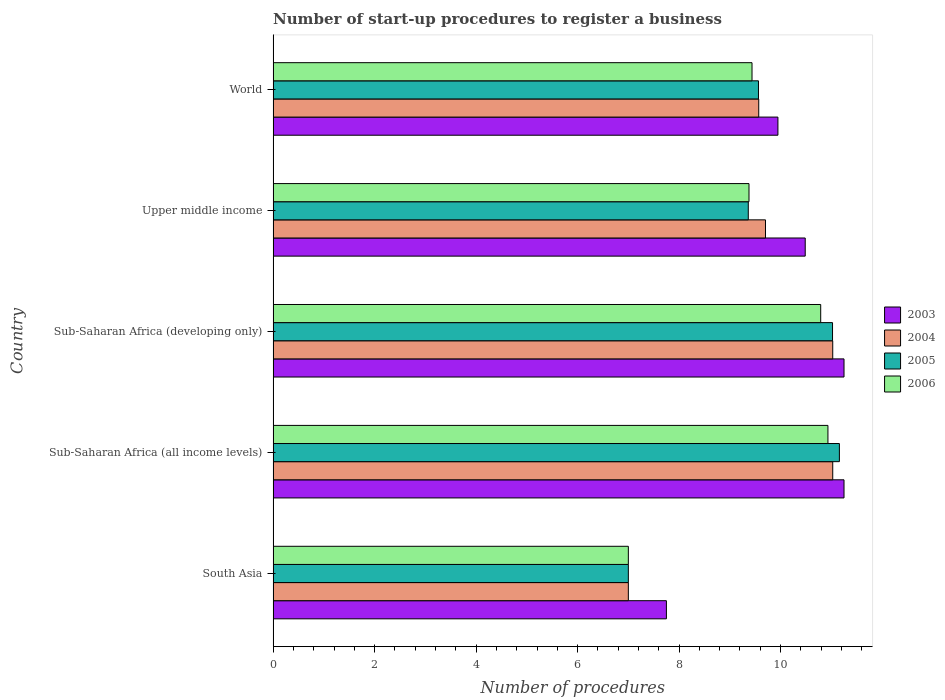How many groups of bars are there?
Offer a very short reply. 5. Are the number of bars per tick equal to the number of legend labels?
Your answer should be compact. Yes. Are the number of bars on each tick of the Y-axis equal?
Your answer should be very brief. Yes. How many bars are there on the 5th tick from the top?
Provide a short and direct response. 4. How many bars are there on the 4th tick from the bottom?
Provide a succinct answer. 4. What is the label of the 2nd group of bars from the top?
Keep it short and to the point. Upper middle income. In how many cases, is the number of bars for a given country not equal to the number of legend labels?
Provide a short and direct response. 0. What is the number of procedures required to register a business in 2006 in World?
Offer a very short reply. 9.44. Across all countries, what is the maximum number of procedures required to register a business in 2006?
Offer a terse response. 10.93. Across all countries, what is the minimum number of procedures required to register a business in 2006?
Provide a succinct answer. 7. In which country was the number of procedures required to register a business in 2006 maximum?
Your answer should be very brief. Sub-Saharan Africa (all income levels). In which country was the number of procedures required to register a business in 2003 minimum?
Offer a terse response. South Asia. What is the total number of procedures required to register a business in 2004 in the graph?
Offer a terse response. 48.33. What is the difference between the number of procedures required to register a business in 2004 in Sub-Saharan Africa (developing only) and that in World?
Offer a very short reply. 1.46. What is the difference between the number of procedures required to register a business in 2005 in South Asia and the number of procedures required to register a business in 2004 in Upper middle income?
Offer a terse response. -2.7. What is the average number of procedures required to register a business in 2004 per country?
Provide a succinct answer. 9.67. What is the difference between the number of procedures required to register a business in 2005 and number of procedures required to register a business in 2006 in World?
Your answer should be very brief. 0.13. In how many countries, is the number of procedures required to register a business in 2003 greater than 0.8 ?
Your response must be concise. 5. What is the ratio of the number of procedures required to register a business in 2004 in South Asia to that in Upper middle income?
Provide a short and direct response. 0.72. Is the difference between the number of procedures required to register a business in 2005 in South Asia and Upper middle income greater than the difference between the number of procedures required to register a business in 2006 in South Asia and Upper middle income?
Ensure brevity in your answer.  Yes. What is the difference between the highest and the second highest number of procedures required to register a business in 2003?
Offer a very short reply. 0. What is the difference between the highest and the lowest number of procedures required to register a business in 2006?
Make the answer very short. 3.93. In how many countries, is the number of procedures required to register a business in 2005 greater than the average number of procedures required to register a business in 2005 taken over all countries?
Your response must be concise. 2. Is it the case that in every country, the sum of the number of procedures required to register a business in 2004 and number of procedures required to register a business in 2005 is greater than the sum of number of procedures required to register a business in 2003 and number of procedures required to register a business in 2006?
Keep it short and to the point. No. What does the 3rd bar from the bottom in World represents?
Provide a succinct answer. 2005. How many bars are there?
Offer a very short reply. 20. What is the difference between two consecutive major ticks on the X-axis?
Your response must be concise. 2. Are the values on the major ticks of X-axis written in scientific E-notation?
Your answer should be compact. No. Does the graph contain grids?
Provide a succinct answer. No. Where does the legend appear in the graph?
Offer a very short reply. Center right. How are the legend labels stacked?
Give a very brief answer. Vertical. What is the title of the graph?
Ensure brevity in your answer.  Number of start-up procedures to register a business. What is the label or title of the X-axis?
Your response must be concise. Number of procedures. What is the Number of procedures of 2003 in South Asia?
Ensure brevity in your answer.  7.75. What is the Number of procedures in 2004 in South Asia?
Your answer should be compact. 7. What is the Number of procedures in 2005 in South Asia?
Offer a terse response. 7. What is the Number of procedures in 2003 in Sub-Saharan Africa (all income levels)?
Offer a very short reply. 11.25. What is the Number of procedures in 2004 in Sub-Saharan Africa (all income levels)?
Offer a very short reply. 11.03. What is the Number of procedures in 2005 in Sub-Saharan Africa (all income levels)?
Offer a terse response. 11.16. What is the Number of procedures of 2006 in Sub-Saharan Africa (all income levels)?
Your response must be concise. 10.93. What is the Number of procedures in 2003 in Sub-Saharan Africa (developing only)?
Make the answer very short. 11.25. What is the Number of procedures of 2004 in Sub-Saharan Africa (developing only)?
Make the answer very short. 11.03. What is the Number of procedures of 2005 in Sub-Saharan Africa (developing only)?
Ensure brevity in your answer.  11.02. What is the Number of procedures in 2006 in Sub-Saharan Africa (developing only)?
Your answer should be compact. 10.79. What is the Number of procedures of 2003 in Upper middle income?
Make the answer very short. 10.49. What is the Number of procedures in 2004 in Upper middle income?
Provide a succinct answer. 9.7. What is the Number of procedures of 2005 in Upper middle income?
Give a very brief answer. 9.36. What is the Number of procedures of 2006 in Upper middle income?
Offer a terse response. 9.38. What is the Number of procedures in 2003 in World?
Offer a terse response. 9.95. What is the Number of procedures of 2004 in World?
Ensure brevity in your answer.  9.57. What is the Number of procedures of 2005 in World?
Your answer should be compact. 9.56. What is the Number of procedures in 2006 in World?
Provide a short and direct response. 9.44. Across all countries, what is the maximum Number of procedures in 2003?
Offer a very short reply. 11.25. Across all countries, what is the maximum Number of procedures in 2004?
Offer a terse response. 11.03. Across all countries, what is the maximum Number of procedures of 2005?
Your answer should be very brief. 11.16. Across all countries, what is the maximum Number of procedures of 2006?
Your answer should be very brief. 10.93. Across all countries, what is the minimum Number of procedures of 2003?
Provide a succinct answer. 7.75. Across all countries, what is the minimum Number of procedures of 2004?
Make the answer very short. 7. Across all countries, what is the minimum Number of procedures of 2005?
Your response must be concise. 7. What is the total Number of procedures in 2003 in the graph?
Your answer should be compact. 50.68. What is the total Number of procedures of 2004 in the graph?
Your response must be concise. 48.33. What is the total Number of procedures in 2005 in the graph?
Provide a short and direct response. 48.11. What is the total Number of procedures in 2006 in the graph?
Give a very brief answer. 47.54. What is the difference between the Number of procedures in 2003 in South Asia and that in Sub-Saharan Africa (all income levels)?
Your response must be concise. -3.5. What is the difference between the Number of procedures of 2004 in South Asia and that in Sub-Saharan Africa (all income levels)?
Give a very brief answer. -4.03. What is the difference between the Number of procedures in 2005 in South Asia and that in Sub-Saharan Africa (all income levels)?
Ensure brevity in your answer.  -4.16. What is the difference between the Number of procedures of 2006 in South Asia and that in Sub-Saharan Africa (all income levels)?
Ensure brevity in your answer.  -3.93. What is the difference between the Number of procedures in 2004 in South Asia and that in Sub-Saharan Africa (developing only)?
Provide a short and direct response. -4.03. What is the difference between the Number of procedures in 2005 in South Asia and that in Sub-Saharan Africa (developing only)?
Provide a succinct answer. -4.02. What is the difference between the Number of procedures in 2006 in South Asia and that in Sub-Saharan Africa (developing only)?
Provide a short and direct response. -3.79. What is the difference between the Number of procedures of 2003 in South Asia and that in Upper middle income?
Give a very brief answer. -2.74. What is the difference between the Number of procedures of 2004 in South Asia and that in Upper middle income?
Offer a very short reply. -2.7. What is the difference between the Number of procedures of 2005 in South Asia and that in Upper middle income?
Keep it short and to the point. -2.36. What is the difference between the Number of procedures of 2006 in South Asia and that in Upper middle income?
Offer a terse response. -2.38. What is the difference between the Number of procedures in 2003 in South Asia and that in World?
Offer a terse response. -2.2. What is the difference between the Number of procedures in 2004 in South Asia and that in World?
Offer a very short reply. -2.57. What is the difference between the Number of procedures of 2005 in South Asia and that in World?
Provide a short and direct response. -2.56. What is the difference between the Number of procedures in 2006 in South Asia and that in World?
Offer a very short reply. -2.44. What is the difference between the Number of procedures of 2005 in Sub-Saharan Africa (all income levels) and that in Sub-Saharan Africa (developing only)?
Provide a short and direct response. 0.14. What is the difference between the Number of procedures of 2006 in Sub-Saharan Africa (all income levels) and that in Sub-Saharan Africa (developing only)?
Give a very brief answer. 0.14. What is the difference between the Number of procedures in 2003 in Sub-Saharan Africa (all income levels) and that in Upper middle income?
Your answer should be compact. 0.76. What is the difference between the Number of procedures in 2004 in Sub-Saharan Africa (all income levels) and that in Upper middle income?
Offer a terse response. 1.33. What is the difference between the Number of procedures in 2005 in Sub-Saharan Africa (all income levels) and that in Upper middle income?
Your answer should be compact. 1.8. What is the difference between the Number of procedures in 2006 in Sub-Saharan Africa (all income levels) and that in Upper middle income?
Make the answer very short. 1.56. What is the difference between the Number of procedures in 2003 in Sub-Saharan Africa (all income levels) and that in World?
Ensure brevity in your answer.  1.3. What is the difference between the Number of procedures of 2004 in Sub-Saharan Africa (all income levels) and that in World?
Provide a succinct answer. 1.46. What is the difference between the Number of procedures of 2005 in Sub-Saharan Africa (all income levels) and that in World?
Make the answer very short. 1.59. What is the difference between the Number of procedures in 2006 in Sub-Saharan Africa (all income levels) and that in World?
Ensure brevity in your answer.  1.5. What is the difference between the Number of procedures of 2003 in Sub-Saharan Africa (developing only) and that in Upper middle income?
Give a very brief answer. 0.76. What is the difference between the Number of procedures in 2004 in Sub-Saharan Africa (developing only) and that in Upper middle income?
Your answer should be very brief. 1.33. What is the difference between the Number of procedures of 2005 in Sub-Saharan Africa (developing only) and that in Upper middle income?
Keep it short and to the point. 1.66. What is the difference between the Number of procedures in 2006 in Sub-Saharan Africa (developing only) and that in Upper middle income?
Give a very brief answer. 1.41. What is the difference between the Number of procedures of 2003 in Sub-Saharan Africa (developing only) and that in World?
Provide a short and direct response. 1.3. What is the difference between the Number of procedures of 2004 in Sub-Saharan Africa (developing only) and that in World?
Offer a very short reply. 1.46. What is the difference between the Number of procedures in 2005 in Sub-Saharan Africa (developing only) and that in World?
Your answer should be very brief. 1.46. What is the difference between the Number of procedures in 2006 in Sub-Saharan Africa (developing only) and that in World?
Give a very brief answer. 1.35. What is the difference between the Number of procedures in 2003 in Upper middle income and that in World?
Your answer should be very brief. 0.54. What is the difference between the Number of procedures in 2004 in Upper middle income and that in World?
Your response must be concise. 0.13. What is the difference between the Number of procedures of 2005 in Upper middle income and that in World?
Give a very brief answer. -0.2. What is the difference between the Number of procedures in 2006 in Upper middle income and that in World?
Offer a very short reply. -0.06. What is the difference between the Number of procedures in 2003 in South Asia and the Number of procedures in 2004 in Sub-Saharan Africa (all income levels)?
Keep it short and to the point. -3.28. What is the difference between the Number of procedures in 2003 in South Asia and the Number of procedures in 2005 in Sub-Saharan Africa (all income levels)?
Make the answer very short. -3.41. What is the difference between the Number of procedures of 2003 in South Asia and the Number of procedures of 2006 in Sub-Saharan Africa (all income levels)?
Give a very brief answer. -3.18. What is the difference between the Number of procedures of 2004 in South Asia and the Number of procedures of 2005 in Sub-Saharan Africa (all income levels)?
Your response must be concise. -4.16. What is the difference between the Number of procedures in 2004 in South Asia and the Number of procedures in 2006 in Sub-Saharan Africa (all income levels)?
Offer a very short reply. -3.93. What is the difference between the Number of procedures of 2005 in South Asia and the Number of procedures of 2006 in Sub-Saharan Africa (all income levels)?
Your answer should be very brief. -3.93. What is the difference between the Number of procedures in 2003 in South Asia and the Number of procedures in 2004 in Sub-Saharan Africa (developing only)?
Your response must be concise. -3.28. What is the difference between the Number of procedures of 2003 in South Asia and the Number of procedures of 2005 in Sub-Saharan Africa (developing only)?
Provide a short and direct response. -3.27. What is the difference between the Number of procedures of 2003 in South Asia and the Number of procedures of 2006 in Sub-Saharan Africa (developing only)?
Your response must be concise. -3.04. What is the difference between the Number of procedures of 2004 in South Asia and the Number of procedures of 2005 in Sub-Saharan Africa (developing only)?
Provide a short and direct response. -4.02. What is the difference between the Number of procedures in 2004 in South Asia and the Number of procedures in 2006 in Sub-Saharan Africa (developing only)?
Make the answer very short. -3.79. What is the difference between the Number of procedures in 2005 in South Asia and the Number of procedures in 2006 in Sub-Saharan Africa (developing only)?
Ensure brevity in your answer.  -3.79. What is the difference between the Number of procedures in 2003 in South Asia and the Number of procedures in 2004 in Upper middle income?
Give a very brief answer. -1.95. What is the difference between the Number of procedures of 2003 in South Asia and the Number of procedures of 2005 in Upper middle income?
Make the answer very short. -1.61. What is the difference between the Number of procedures of 2003 in South Asia and the Number of procedures of 2006 in Upper middle income?
Provide a succinct answer. -1.63. What is the difference between the Number of procedures in 2004 in South Asia and the Number of procedures in 2005 in Upper middle income?
Give a very brief answer. -2.36. What is the difference between the Number of procedures in 2004 in South Asia and the Number of procedures in 2006 in Upper middle income?
Your response must be concise. -2.38. What is the difference between the Number of procedures of 2005 in South Asia and the Number of procedures of 2006 in Upper middle income?
Offer a very short reply. -2.38. What is the difference between the Number of procedures in 2003 in South Asia and the Number of procedures in 2004 in World?
Provide a short and direct response. -1.82. What is the difference between the Number of procedures in 2003 in South Asia and the Number of procedures in 2005 in World?
Your response must be concise. -1.81. What is the difference between the Number of procedures of 2003 in South Asia and the Number of procedures of 2006 in World?
Make the answer very short. -1.69. What is the difference between the Number of procedures of 2004 in South Asia and the Number of procedures of 2005 in World?
Your answer should be very brief. -2.56. What is the difference between the Number of procedures of 2004 in South Asia and the Number of procedures of 2006 in World?
Your response must be concise. -2.44. What is the difference between the Number of procedures of 2005 in South Asia and the Number of procedures of 2006 in World?
Your response must be concise. -2.44. What is the difference between the Number of procedures of 2003 in Sub-Saharan Africa (all income levels) and the Number of procedures of 2004 in Sub-Saharan Africa (developing only)?
Your answer should be compact. 0.22. What is the difference between the Number of procedures of 2003 in Sub-Saharan Africa (all income levels) and the Number of procedures of 2005 in Sub-Saharan Africa (developing only)?
Keep it short and to the point. 0.23. What is the difference between the Number of procedures of 2003 in Sub-Saharan Africa (all income levels) and the Number of procedures of 2006 in Sub-Saharan Africa (developing only)?
Offer a very short reply. 0.46. What is the difference between the Number of procedures in 2004 in Sub-Saharan Africa (all income levels) and the Number of procedures in 2005 in Sub-Saharan Africa (developing only)?
Keep it short and to the point. 0. What is the difference between the Number of procedures of 2004 in Sub-Saharan Africa (all income levels) and the Number of procedures of 2006 in Sub-Saharan Africa (developing only)?
Provide a short and direct response. 0.24. What is the difference between the Number of procedures of 2005 in Sub-Saharan Africa (all income levels) and the Number of procedures of 2006 in Sub-Saharan Africa (developing only)?
Offer a very short reply. 0.37. What is the difference between the Number of procedures of 2003 in Sub-Saharan Africa (all income levels) and the Number of procedures of 2004 in Upper middle income?
Offer a terse response. 1.55. What is the difference between the Number of procedures in 2003 in Sub-Saharan Africa (all income levels) and the Number of procedures in 2005 in Upper middle income?
Your response must be concise. 1.89. What is the difference between the Number of procedures in 2003 in Sub-Saharan Africa (all income levels) and the Number of procedures in 2006 in Upper middle income?
Your answer should be very brief. 1.87. What is the difference between the Number of procedures in 2004 in Sub-Saharan Africa (all income levels) and the Number of procedures in 2005 in Upper middle income?
Your answer should be compact. 1.66. What is the difference between the Number of procedures of 2004 in Sub-Saharan Africa (all income levels) and the Number of procedures of 2006 in Upper middle income?
Your answer should be very brief. 1.65. What is the difference between the Number of procedures of 2005 in Sub-Saharan Africa (all income levels) and the Number of procedures of 2006 in Upper middle income?
Your response must be concise. 1.78. What is the difference between the Number of procedures of 2003 in Sub-Saharan Africa (all income levels) and the Number of procedures of 2004 in World?
Ensure brevity in your answer.  1.68. What is the difference between the Number of procedures of 2003 in Sub-Saharan Africa (all income levels) and the Number of procedures of 2005 in World?
Offer a terse response. 1.69. What is the difference between the Number of procedures of 2003 in Sub-Saharan Africa (all income levels) and the Number of procedures of 2006 in World?
Your response must be concise. 1.81. What is the difference between the Number of procedures of 2004 in Sub-Saharan Africa (all income levels) and the Number of procedures of 2005 in World?
Make the answer very short. 1.46. What is the difference between the Number of procedures of 2004 in Sub-Saharan Africa (all income levels) and the Number of procedures of 2006 in World?
Your answer should be compact. 1.59. What is the difference between the Number of procedures in 2005 in Sub-Saharan Africa (all income levels) and the Number of procedures in 2006 in World?
Make the answer very short. 1.72. What is the difference between the Number of procedures in 2003 in Sub-Saharan Africa (developing only) and the Number of procedures in 2004 in Upper middle income?
Ensure brevity in your answer.  1.55. What is the difference between the Number of procedures of 2003 in Sub-Saharan Africa (developing only) and the Number of procedures of 2005 in Upper middle income?
Your answer should be compact. 1.89. What is the difference between the Number of procedures in 2003 in Sub-Saharan Africa (developing only) and the Number of procedures in 2006 in Upper middle income?
Keep it short and to the point. 1.87. What is the difference between the Number of procedures of 2004 in Sub-Saharan Africa (developing only) and the Number of procedures of 2005 in Upper middle income?
Your answer should be very brief. 1.66. What is the difference between the Number of procedures in 2004 in Sub-Saharan Africa (developing only) and the Number of procedures in 2006 in Upper middle income?
Keep it short and to the point. 1.65. What is the difference between the Number of procedures in 2005 in Sub-Saharan Africa (developing only) and the Number of procedures in 2006 in Upper middle income?
Provide a short and direct response. 1.65. What is the difference between the Number of procedures of 2003 in Sub-Saharan Africa (developing only) and the Number of procedures of 2004 in World?
Ensure brevity in your answer.  1.68. What is the difference between the Number of procedures of 2003 in Sub-Saharan Africa (developing only) and the Number of procedures of 2005 in World?
Provide a short and direct response. 1.69. What is the difference between the Number of procedures in 2003 in Sub-Saharan Africa (developing only) and the Number of procedures in 2006 in World?
Keep it short and to the point. 1.81. What is the difference between the Number of procedures in 2004 in Sub-Saharan Africa (developing only) and the Number of procedures in 2005 in World?
Your response must be concise. 1.46. What is the difference between the Number of procedures of 2004 in Sub-Saharan Africa (developing only) and the Number of procedures of 2006 in World?
Your answer should be compact. 1.59. What is the difference between the Number of procedures in 2005 in Sub-Saharan Africa (developing only) and the Number of procedures in 2006 in World?
Offer a terse response. 1.59. What is the difference between the Number of procedures in 2003 in Upper middle income and the Number of procedures in 2004 in World?
Make the answer very short. 0.92. What is the difference between the Number of procedures in 2003 in Upper middle income and the Number of procedures in 2005 in World?
Give a very brief answer. 0.92. What is the difference between the Number of procedures of 2003 in Upper middle income and the Number of procedures of 2006 in World?
Offer a very short reply. 1.05. What is the difference between the Number of procedures of 2004 in Upper middle income and the Number of procedures of 2005 in World?
Offer a very short reply. 0.14. What is the difference between the Number of procedures of 2004 in Upper middle income and the Number of procedures of 2006 in World?
Make the answer very short. 0.27. What is the difference between the Number of procedures in 2005 in Upper middle income and the Number of procedures in 2006 in World?
Provide a short and direct response. -0.07. What is the average Number of procedures in 2003 per country?
Offer a very short reply. 10.14. What is the average Number of procedures of 2004 per country?
Provide a short and direct response. 9.67. What is the average Number of procedures of 2005 per country?
Your answer should be very brief. 9.62. What is the average Number of procedures of 2006 per country?
Make the answer very short. 9.51. What is the difference between the Number of procedures of 2003 and Number of procedures of 2004 in South Asia?
Provide a succinct answer. 0.75. What is the difference between the Number of procedures of 2004 and Number of procedures of 2005 in South Asia?
Give a very brief answer. 0. What is the difference between the Number of procedures of 2004 and Number of procedures of 2006 in South Asia?
Offer a terse response. 0. What is the difference between the Number of procedures in 2005 and Number of procedures in 2006 in South Asia?
Your answer should be very brief. 0. What is the difference between the Number of procedures in 2003 and Number of procedures in 2004 in Sub-Saharan Africa (all income levels)?
Make the answer very short. 0.22. What is the difference between the Number of procedures in 2003 and Number of procedures in 2005 in Sub-Saharan Africa (all income levels)?
Keep it short and to the point. 0.09. What is the difference between the Number of procedures of 2003 and Number of procedures of 2006 in Sub-Saharan Africa (all income levels)?
Provide a short and direct response. 0.32. What is the difference between the Number of procedures of 2004 and Number of procedures of 2005 in Sub-Saharan Africa (all income levels)?
Keep it short and to the point. -0.13. What is the difference between the Number of procedures of 2004 and Number of procedures of 2006 in Sub-Saharan Africa (all income levels)?
Your response must be concise. 0.09. What is the difference between the Number of procedures of 2005 and Number of procedures of 2006 in Sub-Saharan Africa (all income levels)?
Provide a short and direct response. 0.23. What is the difference between the Number of procedures in 2003 and Number of procedures in 2004 in Sub-Saharan Africa (developing only)?
Your answer should be compact. 0.22. What is the difference between the Number of procedures of 2003 and Number of procedures of 2005 in Sub-Saharan Africa (developing only)?
Make the answer very short. 0.23. What is the difference between the Number of procedures of 2003 and Number of procedures of 2006 in Sub-Saharan Africa (developing only)?
Ensure brevity in your answer.  0.46. What is the difference between the Number of procedures in 2004 and Number of procedures in 2005 in Sub-Saharan Africa (developing only)?
Your answer should be very brief. 0. What is the difference between the Number of procedures in 2004 and Number of procedures in 2006 in Sub-Saharan Africa (developing only)?
Your response must be concise. 0.24. What is the difference between the Number of procedures of 2005 and Number of procedures of 2006 in Sub-Saharan Africa (developing only)?
Provide a short and direct response. 0.23. What is the difference between the Number of procedures of 2003 and Number of procedures of 2004 in Upper middle income?
Provide a short and direct response. 0.78. What is the difference between the Number of procedures in 2003 and Number of procedures in 2005 in Upper middle income?
Provide a succinct answer. 1.12. What is the difference between the Number of procedures in 2003 and Number of procedures in 2006 in Upper middle income?
Give a very brief answer. 1.11. What is the difference between the Number of procedures of 2004 and Number of procedures of 2005 in Upper middle income?
Keep it short and to the point. 0.34. What is the difference between the Number of procedures of 2004 and Number of procedures of 2006 in Upper middle income?
Keep it short and to the point. 0.32. What is the difference between the Number of procedures in 2005 and Number of procedures in 2006 in Upper middle income?
Offer a terse response. -0.01. What is the difference between the Number of procedures of 2003 and Number of procedures of 2004 in World?
Give a very brief answer. 0.38. What is the difference between the Number of procedures of 2003 and Number of procedures of 2005 in World?
Provide a short and direct response. 0.38. What is the difference between the Number of procedures of 2003 and Number of procedures of 2006 in World?
Make the answer very short. 0.51. What is the difference between the Number of procedures in 2004 and Number of procedures in 2005 in World?
Keep it short and to the point. 0.01. What is the difference between the Number of procedures in 2004 and Number of procedures in 2006 in World?
Provide a succinct answer. 0.13. What is the difference between the Number of procedures of 2005 and Number of procedures of 2006 in World?
Your answer should be very brief. 0.13. What is the ratio of the Number of procedures of 2003 in South Asia to that in Sub-Saharan Africa (all income levels)?
Provide a succinct answer. 0.69. What is the ratio of the Number of procedures in 2004 in South Asia to that in Sub-Saharan Africa (all income levels)?
Offer a very short reply. 0.63. What is the ratio of the Number of procedures in 2005 in South Asia to that in Sub-Saharan Africa (all income levels)?
Keep it short and to the point. 0.63. What is the ratio of the Number of procedures of 2006 in South Asia to that in Sub-Saharan Africa (all income levels)?
Make the answer very short. 0.64. What is the ratio of the Number of procedures of 2003 in South Asia to that in Sub-Saharan Africa (developing only)?
Keep it short and to the point. 0.69. What is the ratio of the Number of procedures in 2004 in South Asia to that in Sub-Saharan Africa (developing only)?
Provide a short and direct response. 0.63. What is the ratio of the Number of procedures in 2005 in South Asia to that in Sub-Saharan Africa (developing only)?
Offer a very short reply. 0.64. What is the ratio of the Number of procedures of 2006 in South Asia to that in Sub-Saharan Africa (developing only)?
Ensure brevity in your answer.  0.65. What is the ratio of the Number of procedures of 2003 in South Asia to that in Upper middle income?
Your answer should be very brief. 0.74. What is the ratio of the Number of procedures of 2004 in South Asia to that in Upper middle income?
Offer a very short reply. 0.72. What is the ratio of the Number of procedures of 2005 in South Asia to that in Upper middle income?
Provide a succinct answer. 0.75. What is the ratio of the Number of procedures in 2006 in South Asia to that in Upper middle income?
Provide a succinct answer. 0.75. What is the ratio of the Number of procedures of 2003 in South Asia to that in World?
Your answer should be compact. 0.78. What is the ratio of the Number of procedures in 2004 in South Asia to that in World?
Ensure brevity in your answer.  0.73. What is the ratio of the Number of procedures of 2005 in South Asia to that in World?
Provide a succinct answer. 0.73. What is the ratio of the Number of procedures of 2006 in South Asia to that in World?
Your response must be concise. 0.74. What is the ratio of the Number of procedures of 2003 in Sub-Saharan Africa (all income levels) to that in Sub-Saharan Africa (developing only)?
Make the answer very short. 1. What is the ratio of the Number of procedures in 2004 in Sub-Saharan Africa (all income levels) to that in Sub-Saharan Africa (developing only)?
Your answer should be compact. 1. What is the ratio of the Number of procedures in 2005 in Sub-Saharan Africa (all income levels) to that in Sub-Saharan Africa (developing only)?
Your response must be concise. 1.01. What is the ratio of the Number of procedures of 2006 in Sub-Saharan Africa (all income levels) to that in Sub-Saharan Africa (developing only)?
Provide a short and direct response. 1.01. What is the ratio of the Number of procedures in 2003 in Sub-Saharan Africa (all income levels) to that in Upper middle income?
Keep it short and to the point. 1.07. What is the ratio of the Number of procedures in 2004 in Sub-Saharan Africa (all income levels) to that in Upper middle income?
Offer a very short reply. 1.14. What is the ratio of the Number of procedures of 2005 in Sub-Saharan Africa (all income levels) to that in Upper middle income?
Give a very brief answer. 1.19. What is the ratio of the Number of procedures of 2006 in Sub-Saharan Africa (all income levels) to that in Upper middle income?
Offer a terse response. 1.17. What is the ratio of the Number of procedures in 2003 in Sub-Saharan Africa (all income levels) to that in World?
Your answer should be compact. 1.13. What is the ratio of the Number of procedures of 2004 in Sub-Saharan Africa (all income levels) to that in World?
Your response must be concise. 1.15. What is the ratio of the Number of procedures in 2006 in Sub-Saharan Africa (all income levels) to that in World?
Make the answer very short. 1.16. What is the ratio of the Number of procedures of 2003 in Sub-Saharan Africa (developing only) to that in Upper middle income?
Your answer should be very brief. 1.07. What is the ratio of the Number of procedures in 2004 in Sub-Saharan Africa (developing only) to that in Upper middle income?
Your answer should be very brief. 1.14. What is the ratio of the Number of procedures in 2005 in Sub-Saharan Africa (developing only) to that in Upper middle income?
Provide a short and direct response. 1.18. What is the ratio of the Number of procedures of 2006 in Sub-Saharan Africa (developing only) to that in Upper middle income?
Offer a terse response. 1.15. What is the ratio of the Number of procedures of 2003 in Sub-Saharan Africa (developing only) to that in World?
Your answer should be very brief. 1.13. What is the ratio of the Number of procedures of 2004 in Sub-Saharan Africa (developing only) to that in World?
Provide a succinct answer. 1.15. What is the ratio of the Number of procedures in 2005 in Sub-Saharan Africa (developing only) to that in World?
Your answer should be compact. 1.15. What is the ratio of the Number of procedures of 2006 in Sub-Saharan Africa (developing only) to that in World?
Offer a terse response. 1.14. What is the ratio of the Number of procedures of 2003 in Upper middle income to that in World?
Your response must be concise. 1.05. What is the ratio of the Number of procedures in 2004 in Upper middle income to that in World?
Offer a very short reply. 1.01. What is the ratio of the Number of procedures of 2006 in Upper middle income to that in World?
Offer a very short reply. 0.99. What is the difference between the highest and the second highest Number of procedures in 2005?
Your response must be concise. 0.14. What is the difference between the highest and the second highest Number of procedures of 2006?
Provide a short and direct response. 0.14. What is the difference between the highest and the lowest Number of procedures of 2004?
Your answer should be very brief. 4.03. What is the difference between the highest and the lowest Number of procedures in 2005?
Offer a terse response. 4.16. What is the difference between the highest and the lowest Number of procedures in 2006?
Provide a succinct answer. 3.93. 